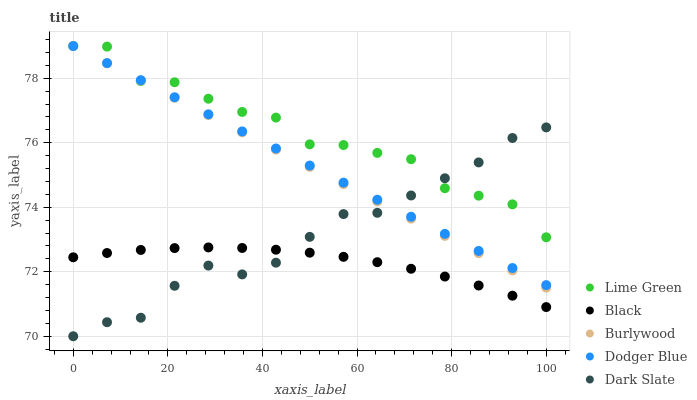Does Black have the minimum area under the curve?
Answer yes or no. Yes. Does Lime Green have the maximum area under the curve?
Answer yes or no. Yes. Does Lime Green have the minimum area under the curve?
Answer yes or no. No. Does Black have the maximum area under the curve?
Answer yes or no. No. Is Burlywood the smoothest?
Answer yes or no. Yes. Is Lime Green the roughest?
Answer yes or no. Yes. Is Black the smoothest?
Answer yes or no. No. Is Black the roughest?
Answer yes or no. No. Does Dark Slate have the lowest value?
Answer yes or no. Yes. Does Black have the lowest value?
Answer yes or no. No. Does Dodger Blue have the highest value?
Answer yes or no. Yes. Does Black have the highest value?
Answer yes or no. No. Is Black less than Dodger Blue?
Answer yes or no. Yes. Is Burlywood greater than Black?
Answer yes or no. Yes. Does Dark Slate intersect Black?
Answer yes or no. Yes. Is Dark Slate less than Black?
Answer yes or no. No. Is Dark Slate greater than Black?
Answer yes or no. No. Does Black intersect Dodger Blue?
Answer yes or no. No. 